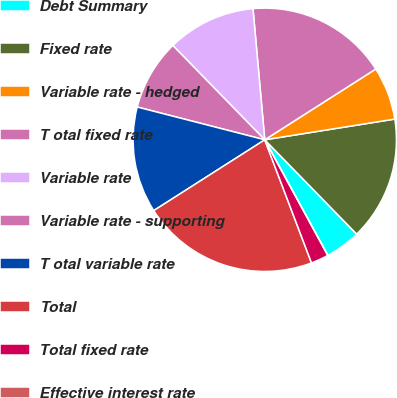Convert chart. <chart><loc_0><loc_0><loc_500><loc_500><pie_chart><fcel>Debt Summary<fcel>Fixed rate<fcel>Variable rate - hedged<fcel>T otal fixed rate<fcel>Variable rate<fcel>Variable rate - supporting<fcel>T otal variable rate<fcel>Total<fcel>Total fixed rate<fcel>Effective interest rate<nl><fcel>4.35%<fcel>15.22%<fcel>6.52%<fcel>17.39%<fcel>10.87%<fcel>8.7%<fcel>13.04%<fcel>21.74%<fcel>2.17%<fcel>0.0%<nl></chart> 